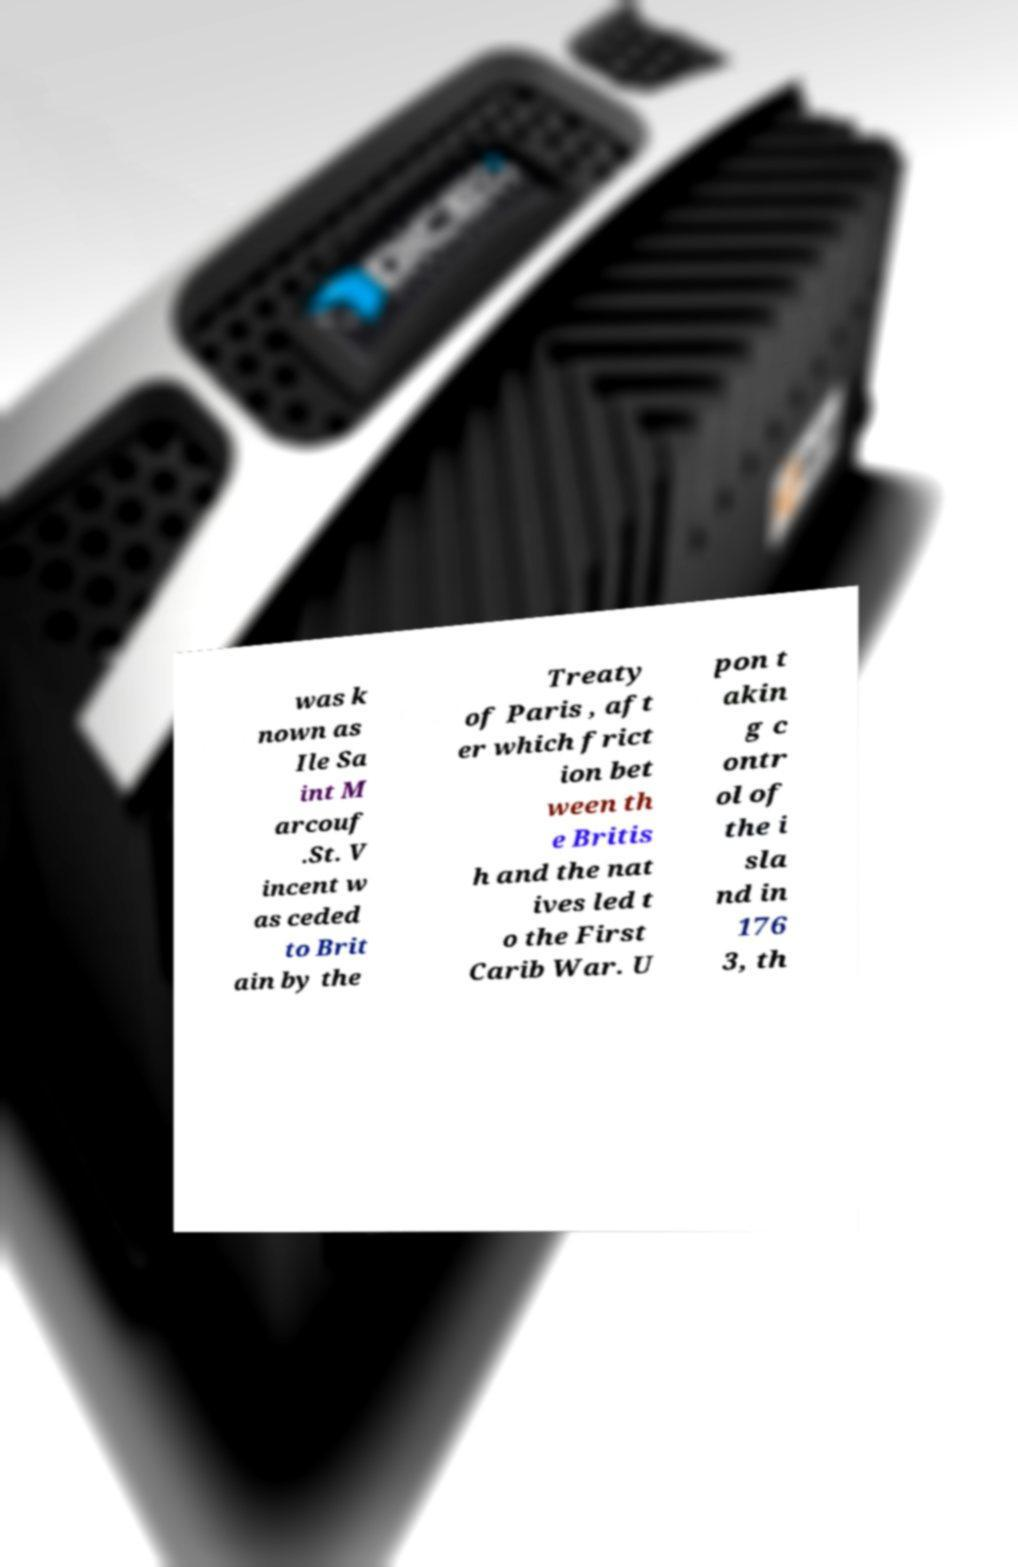Can you read and provide the text displayed in the image?This photo seems to have some interesting text. Can you extract and type it out for me? was k nown as Ile Sa int M arcouf .St. V incent w as ceded to Brit ain by the Treaty of Paris , aft er which frict ion bet ween th e Britis h and the nat ives led t o the First Carib War. U pon t akin g c ontr ol of the i sla nd in 176 3, th 